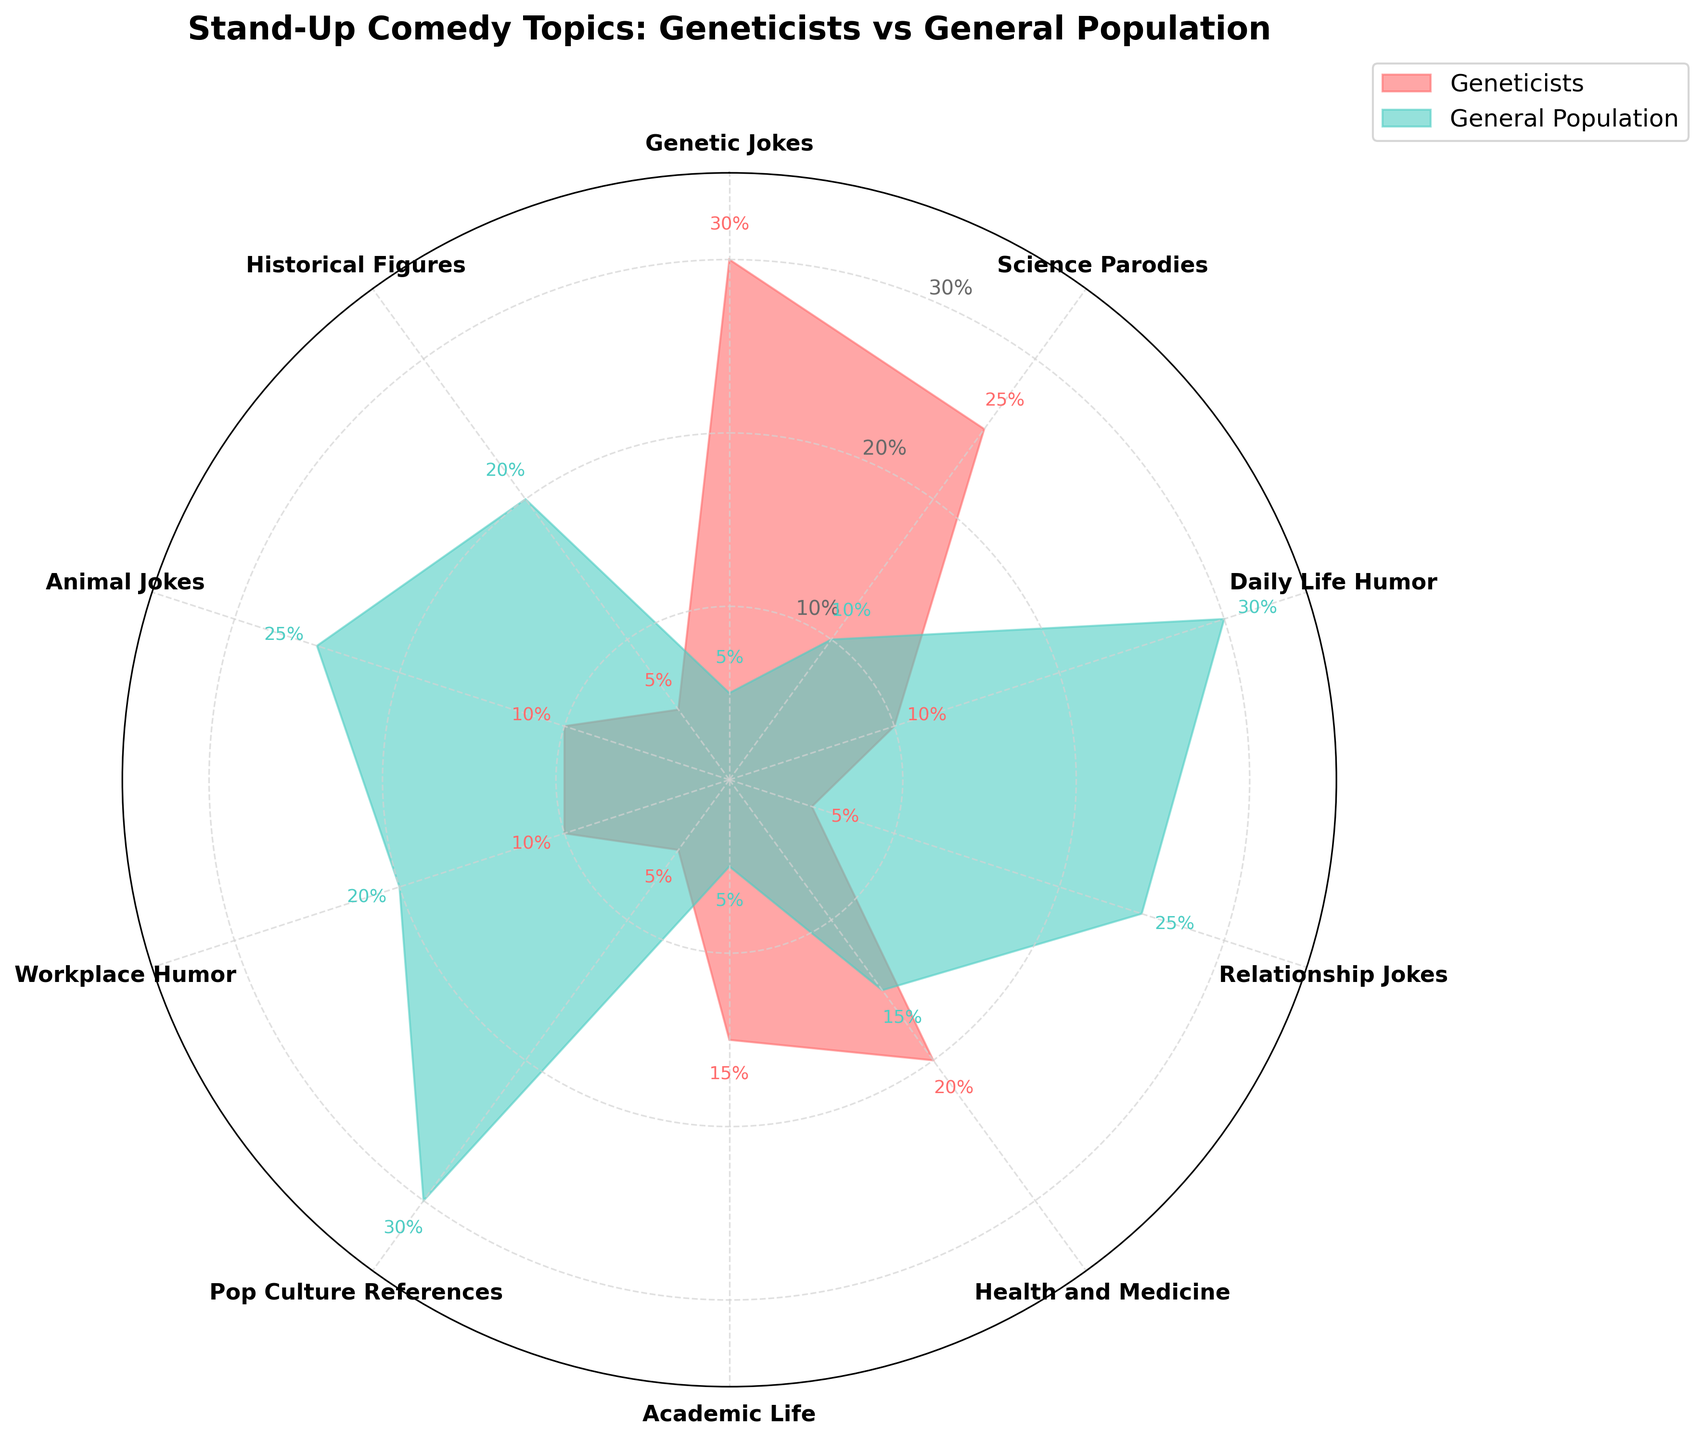What is the title of the chart? The title of the chart is located at the top center. It reads "Stand-Up Comedy Topics: Geneticists vs General Population."
Answer: "Stand-Up Comedy Topics: Geneticists vs General Population" How many categories of comedy topics are compared? The chart has labels arranged around the circle. There are 10 different categories.
Answer: 10 Which topic is most preferred by geneticists? By examining the filled area representing geneticists (in red) and reading the percentages, "Genetic Jokes" has the highest percentage, at 30%.
Answer: Genetic Jokes Which topic shows the biggest difference in preference between the two groups? By comparing the differences visually and checking the percentages, "Genetic Jokes" (30% vs 5%) shows the largest difference of 25%.
Answer: Genetic Jokes What is the average preference percentage for geneticists across all topics? Sum up the percentages for geneticists across all topics and divide by the number of categories. (30 + 25 + 10 + 5 + 20 + 15 + 5 + 10 + 10 + 5) / 10 = 13.5%
Answer: 13.5% What is the preference percentage for "Science Parodies" for both groups combined? Add the preferences for both groups in the "Science Parodies" category. 25% (Geneticists) + 10% (General Population) = 35%
Answer: 35% Which group prefers "Daily Life Humor" more? By comparing the lengths of the filled areas and their percentages, the general population prefers "Daily Life Humor" significantly more (30% vs 10%).
Answer: General Population Are there any topics equally preferred by both groups? By checking the percentages for both groups on each category, no topics have equal preference percentages.
Answer: No What's the median preference value for the general population across all topics? To find the median, list all the percentages for the general population in order and find the middle value. Values: 5, 5, 10, 15, 20, 25, 25, 25, 30, 30. Median is (20+25)/2 = 22.5%
Answer: 22.5% Which two categories have the same preference percentage for geneticists? By examining the percentages visually and looking for equal values, "Daily Life Humor" and "Animal Jokes," both at 10%, have the same preference percentage.
Answer: Daily Life Humor and Animal Jokes 